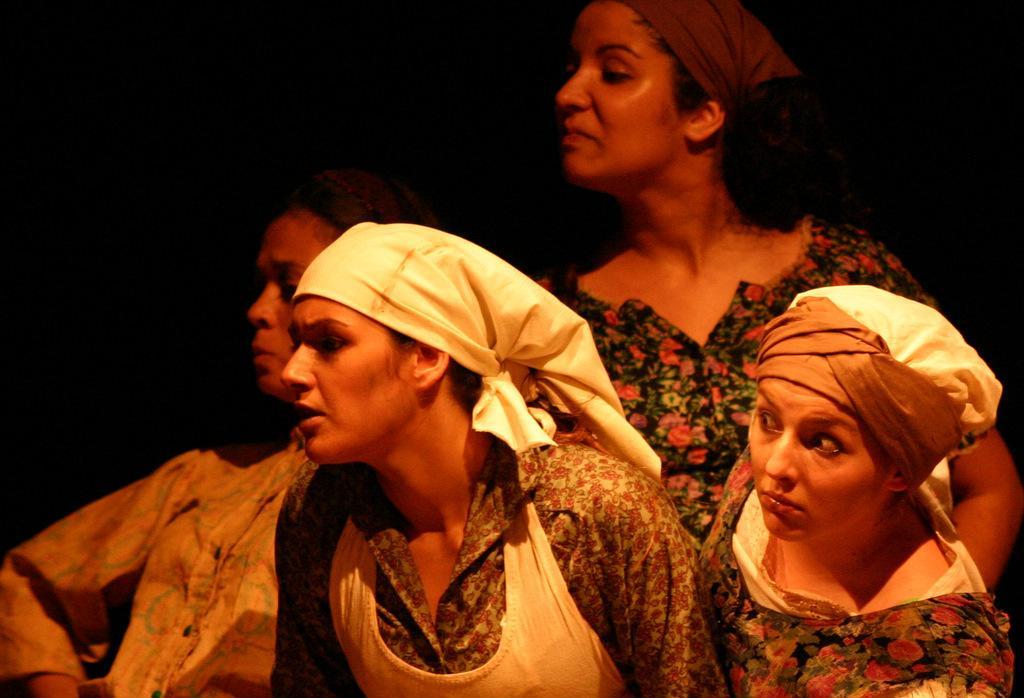Please provide a concise description of this image. There is a group of people present as we can see at the bottom of this image and it is dark in the background. 